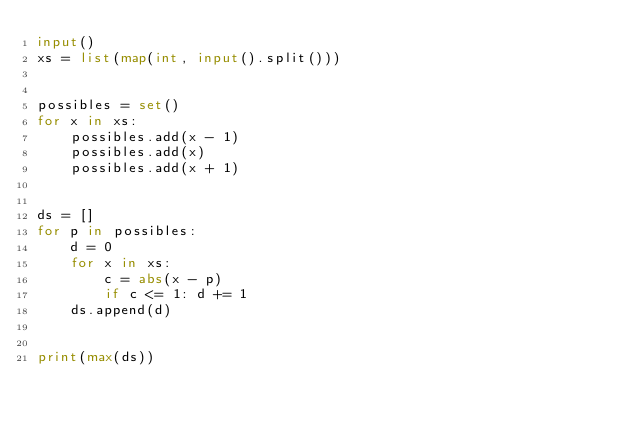<code> <loc_0><loc_0><loc_500><loc_500><_Python_>input()
xs = list(map(int, input().split()))


possibles = set()
for x in xs:
    possibles.add(x - 1)
    possibles.add(x)
    possibles.add(x + 1)


ds = []
for p in possibles:
    d = 0
    for x in xs:
        c = abs(x - p)
        if c <= 1: d += 1
    ds.append(d)


print(max(ds))





</code> 